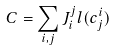Convert formula to latex. <formula><loc_0><loc_0><loc_500><loc_500>C = \sum _ { i , j } J ^ { j } _ { i } l ( c ^ { i } _ { j } )</formula> 